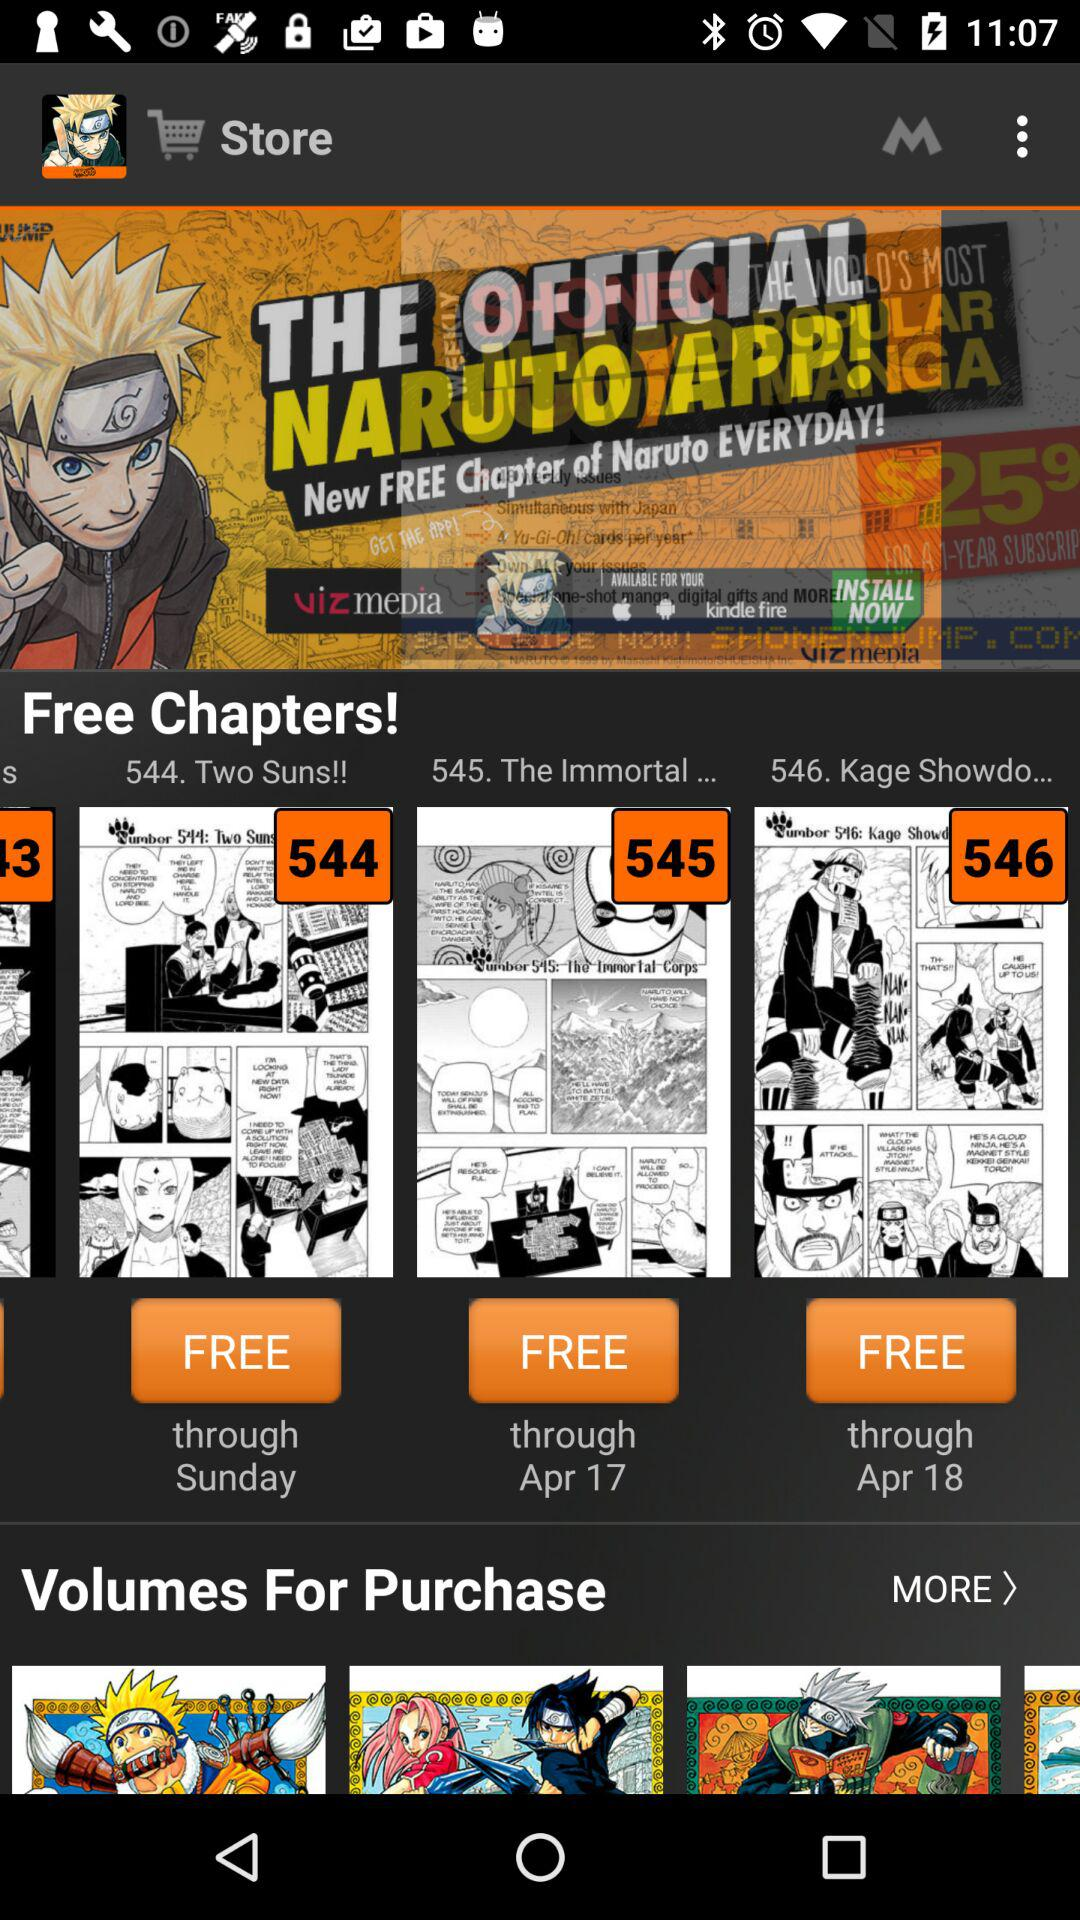What is the name of the chapter that is free through Sunday? The name of the chapter is "Two Suns!!". 